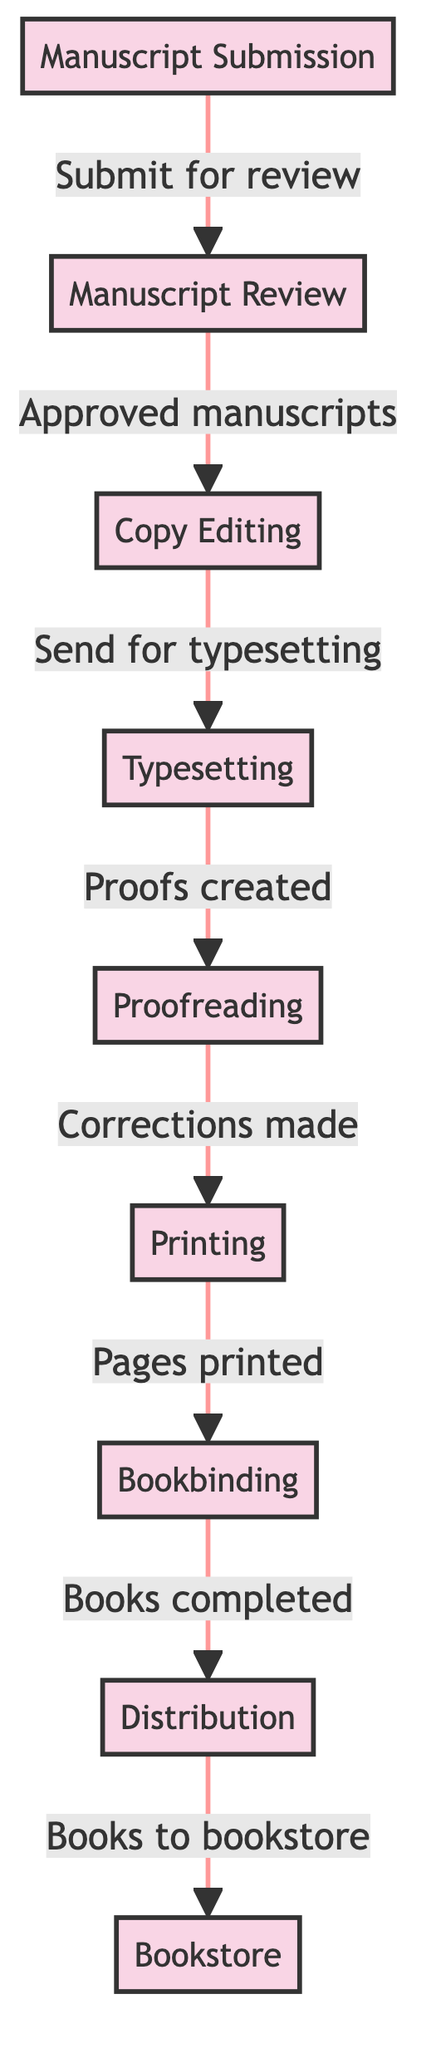What is the first step in the book printing process? The diagram shows "Manuscript Submission" as the starting point, indicating that it is the first step in the workflow of book printing.
Answer: Manuscript Submission How many steps are there in the workflow? By counting the nodes in the diagram, we can identify that there are a total of nine steps from "Manuscript Submission" to "Bookstore."
Answer: 9 What step comes after Proofreading? The diagram indicates that "Printing" directly follows "Proofreading," making it the next step in the sequence.
Answer: Printing What is the last step before the books reach the bookstore? The step preceding the "Bookstore" is "Distribution," which is the final step before the books are sent to retailers.
Answer: Distribution Which step involves creating proofs? In the workflow, "Proofs created" is explicitly mentioned in the step "Typesetting," indicating that this is where proofs are first created.
Answer: Typesetting What is the relationship between Copy Editing and Typesetting? The diagram shows that "Copy Editing" leads to "Typesetting," indicating that approved manuscripts go through editing before they are typeset.
Answer: Copy Editing leads to Typesetting What action is taken after Corrections are made? According to the diagram, the step that follows "Corrections made" is "Printing," implying that once corrections have been applied, the printing process can begin.
Answer: Printing Which step involves sending books to the bookstore? The diagram shows "Books to bookstore" as part of the "Distribution" stage, indicating that this step is responsible for sending completed books to retailers.
Answer: Books to bookstore What happens after the Manuscript Review? The flow shows that after the "Manuscript Review," approved manuscripts proceed to "Copy Editing," marking the next phase in the workflow.
Answer: Copy Editing 